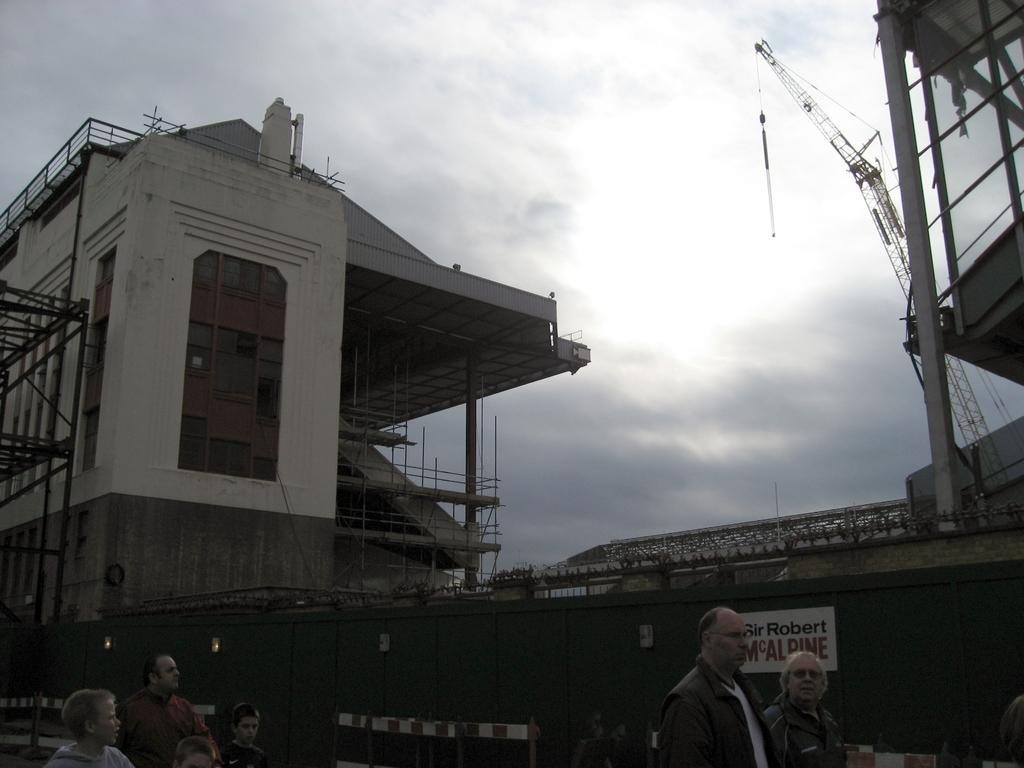Who or what can be seen at the bottom of the image? There are people at the bottom of the image. What is on the wall in the image? There is a poster on a wall. What type of structures can be seen in the background? There are buildings in the background. What is the crane used for in the image? The crane is visible in the background, but its purpose is not specified in the image. What can be seen in the sky in the image? Clouds are present in the background. What type of education is being offered through the door in the image? There is no door present in the image, so it is not possible to determine what type of education might be offered. What season is depicted in the image, considering the presence of clouds and the absence of summer-related elements? The image does not specify a season, and the presence of clouds does not necessarily indicate a particular season. 